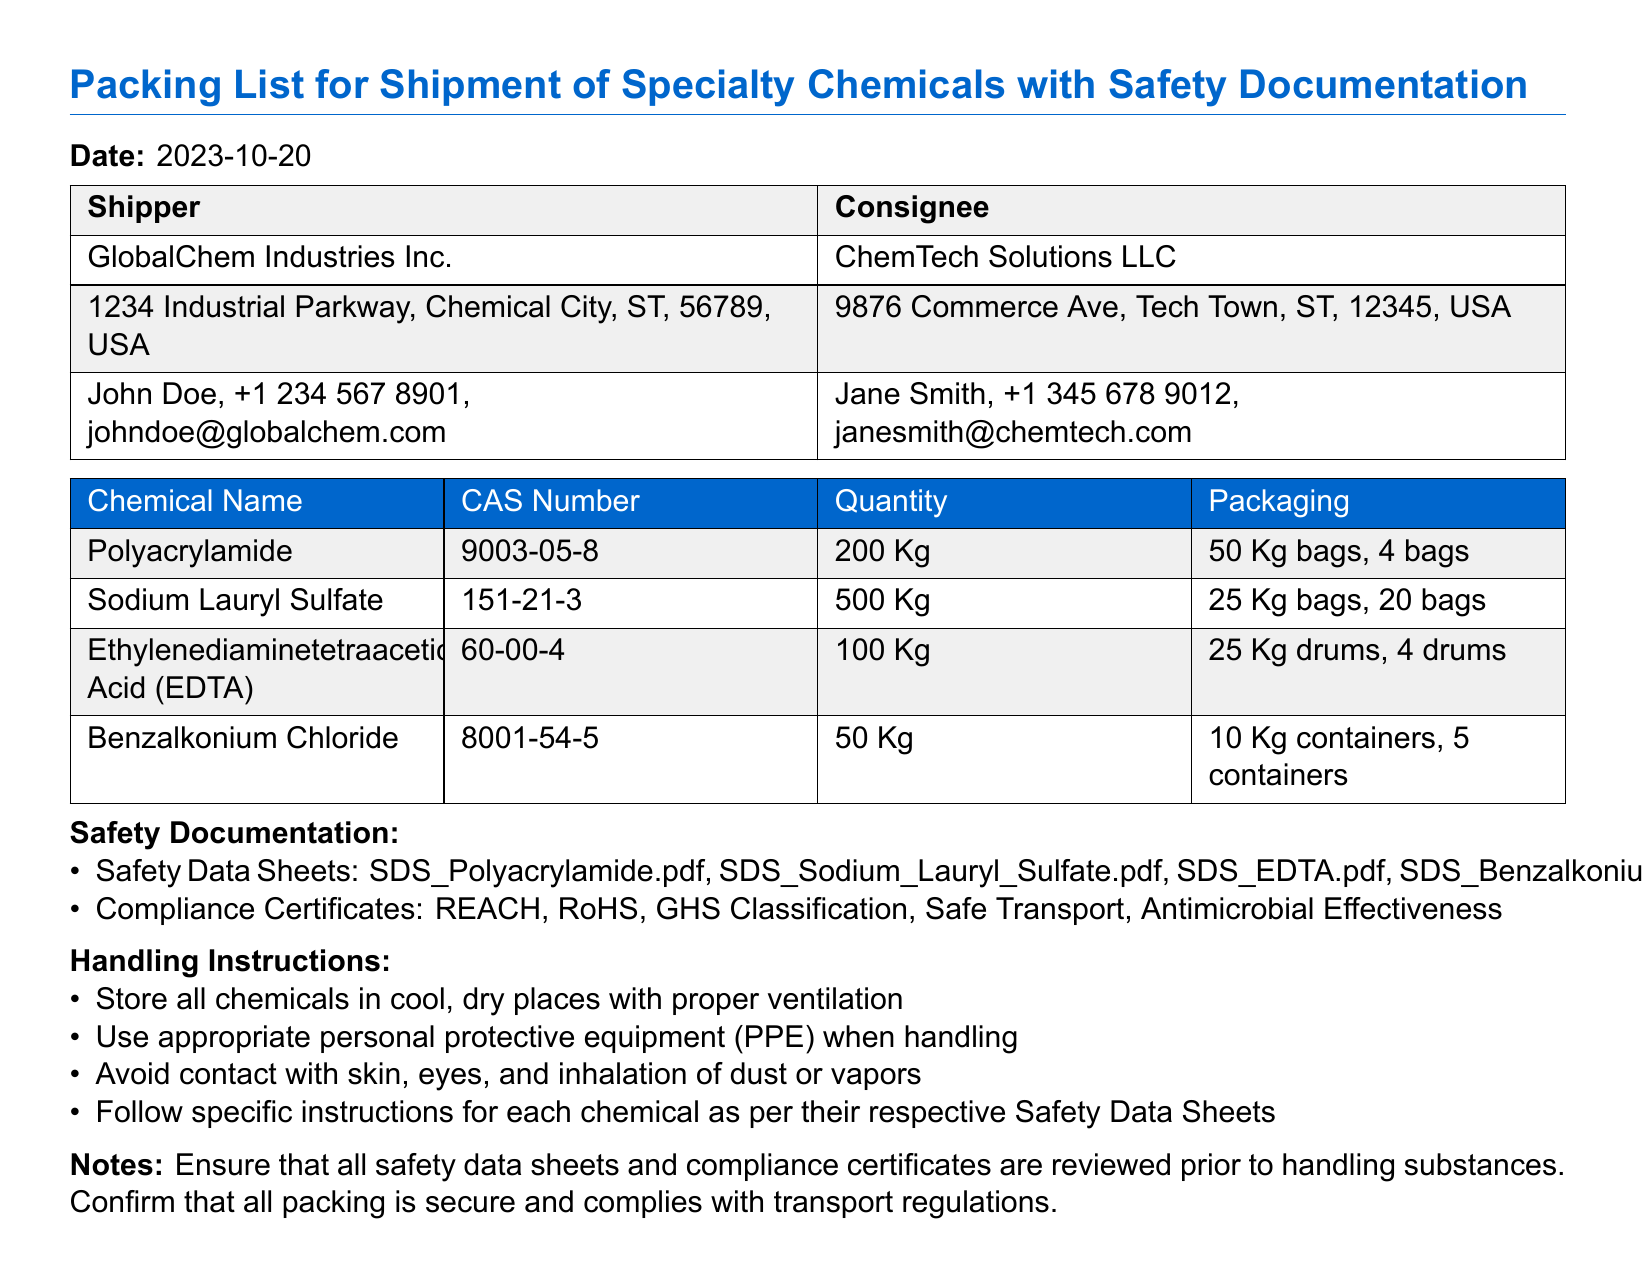What is the date of the packing list? The date mentioned at the top of the document specifies when the packing list was created.
Answer: 2023-10-20 Who is the shipper? The shipper is detailed in the document and is essential for identifying the sender of the shipment.
Answer: GlobalChem Industries Inc What is the quantity of Sodium Lauryl Sulfate? The document lists the exact amount of each chemical, a critical piece of information for inventory.
Answer: 500 Kg What are the compliance certificates listed? The compliance certificates ensure various standards and regulations are met, and they are listed under safety documentation.
Answer: REACH, RoHS, GHS Classification, Safe Transport, Antimicrobial Effectiveness How many Polyacrylamide bags are included in the shipment? The number of bags is provided in the documentation, which is important for logistics and handling.
Answer: 4 bags What is one of the handling instructions? The handling instructions outline how to safely deal with the chemicals, ensuring safety during handling.
Answer: Store all chemicals in cool, dry places with proper ventilation Which chemical has a CAS number of 60-00-4? The CAS number is a unique identifier for chemicals, and this information assists in recognizing the specific chemical.
Answer: Ethylenediaminetetraacetic Acid (EDTA) What type of packaging is used for Benzalkonium Chloride? The packaging type is crucial for understanding how the chemical is contained and transported.
Answer: 10 Kg containers What is noted about safety data sheets? The notes provide guidance on how to approach the safety data sheets and their importance in handling the chemicals.
Answer: Ensure that all safety data sheets and compliance certificates are reviewed prior to handling substances 